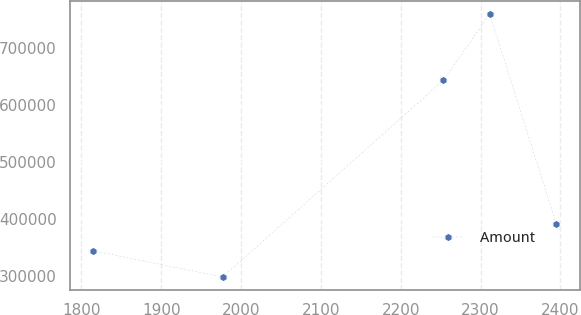<chart> <loc_0><loc_0><loc_500><loc_500><line_chart><ecel><fcel>Amount<nl><fcel>1814.51<fcel>344785<nl><fcel>1977<fcel>298638<nl><fcel>2253.51<fcel>644035<nl><fcel>2311.57<fcel>760113<nl><fcel>2395.08<fcel>390933<nl></chart> 